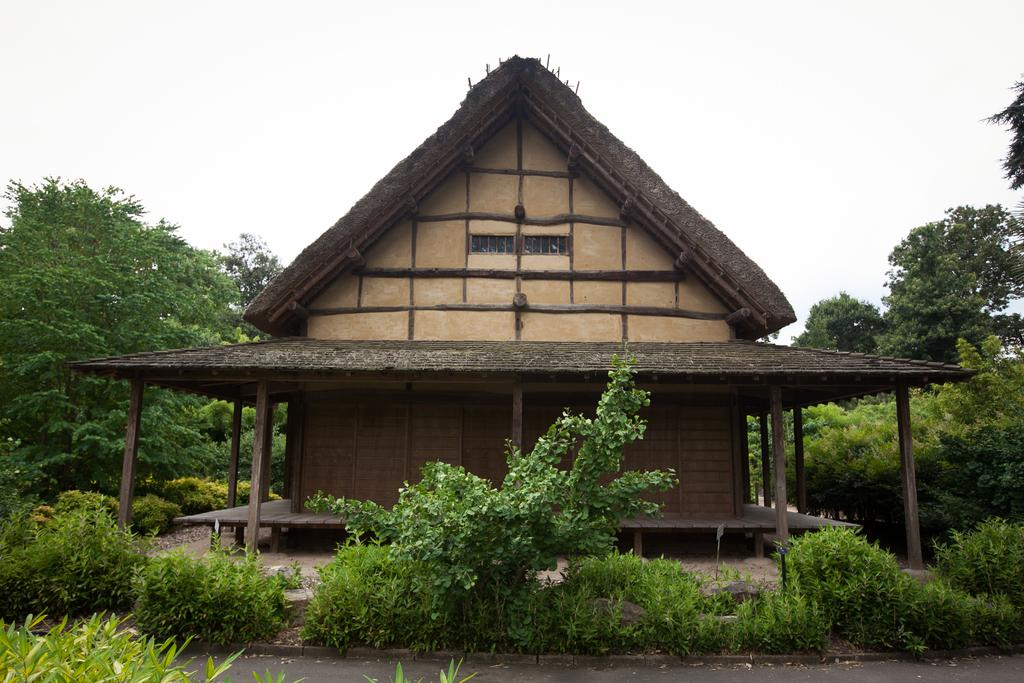What is visible in the image? Water is visible in the image. What can be found at the bottom of the image? There are plants at the bottom of the image. What structures are visible in the background of the image? There is a house and trees in the background of the image. What part of the natural environment is visible in the image? The sky is visible in the background of the image. How does the spade help to increase respect in the image? There is no spade present in the image, and therefore it cannot help to increase respect. 